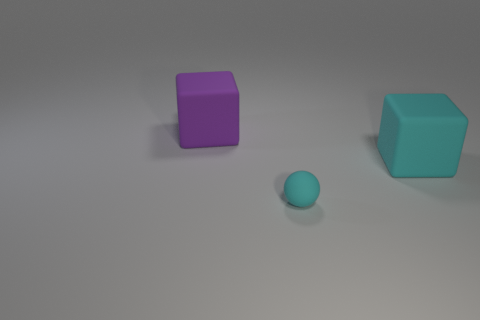Add 2 cyan rubber cubes. How many objects exist? 5 Subtract all balls. How many objects are left? 2 Subtract 0 yellow spheres. How many objects are left? 3 Subtract all big purple blocks. Subtract all big cyan blocks. How many objects are left? 1 Add 2 small matte objects. How many small matte objects are left? 3 Add 2 green metallic objects. How many green metallic objects exist? 2 